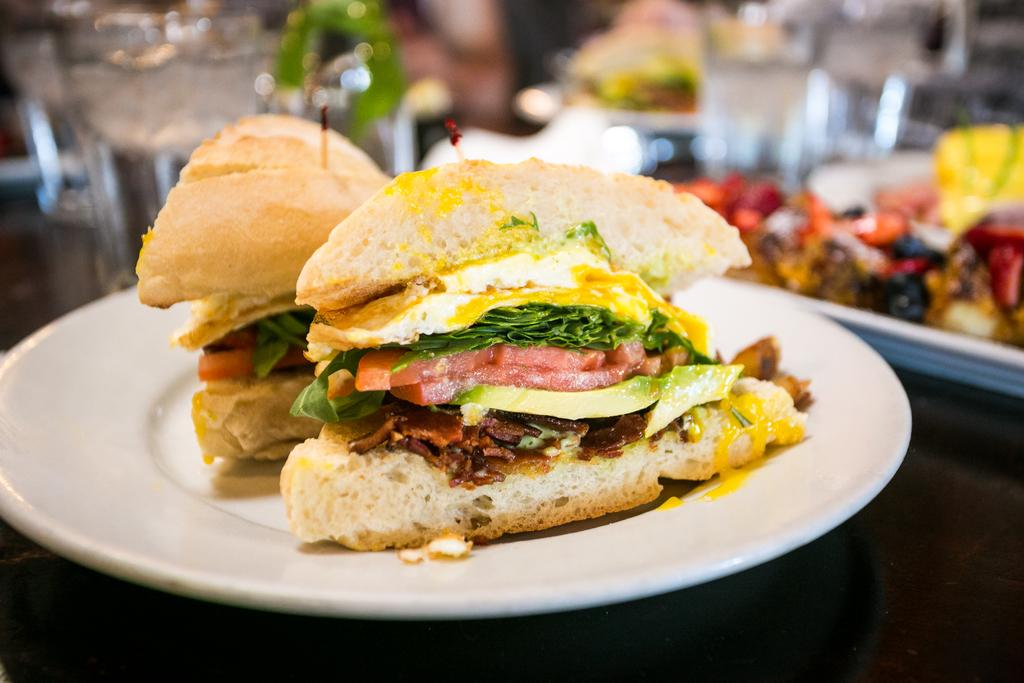What type of food can be seen in the image? There is a food item in the image, but the specific type cannot be determined from the provided facts. What colors are present in the food item? The food has brown, white, yellow, green, and red colors. Can you describe the background of the image? The background of the image is blurred. How many frogs are sitting on the food item in the image? There are no frogs present in the image. What type of food is being folded in the image? There is no food being folded in the image. 